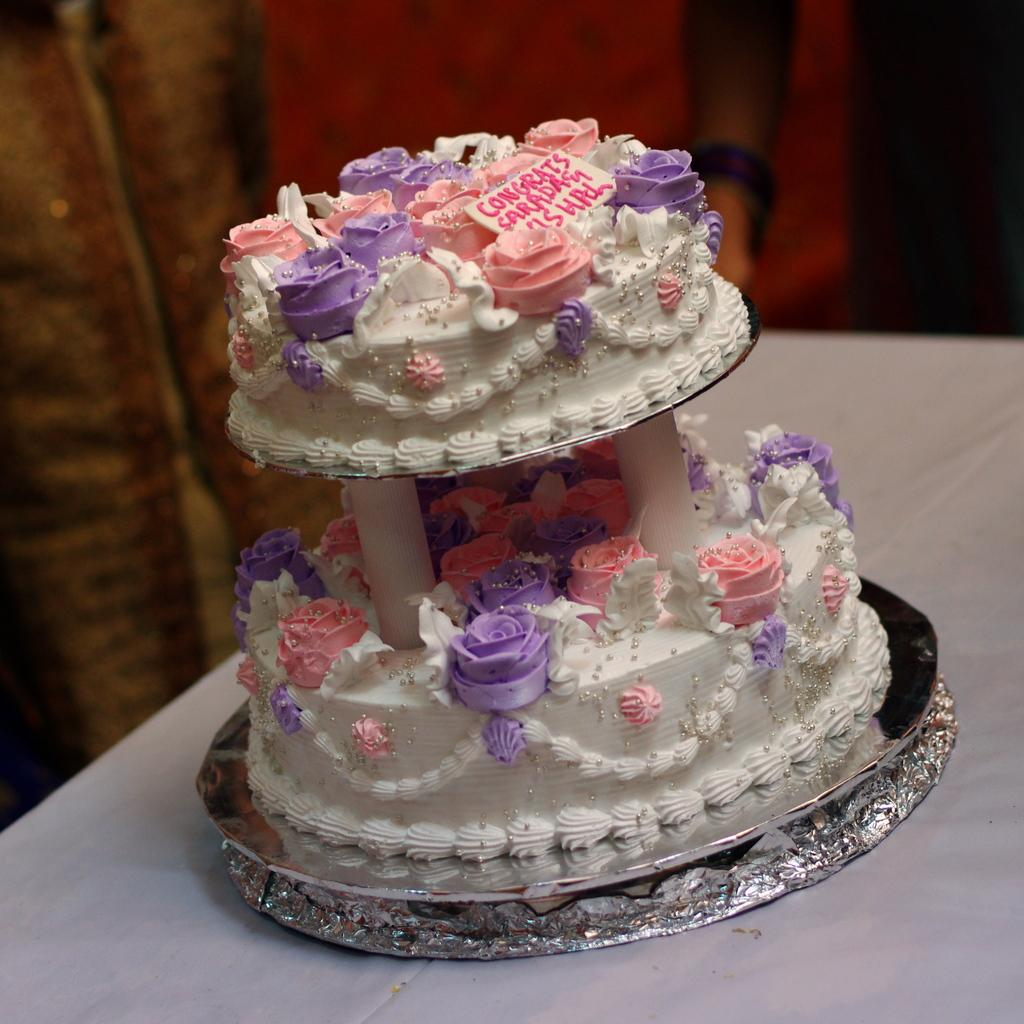What is on the table in the image? There is a cake on the table. What can be seen on the cake? There is text on the cake. How is the table decorated or covered? The table is covered with a white cloth. Are there any people present in the image? Yes, there are two persons standing at the back. What type of instrument is being played by the cake in the image? There is no instrument being played by the cake in the image, as it is a stationary object. Can you tell me how many loaves of bread are on the table? There is no bread present on the table in the image; it features a cake instead. 